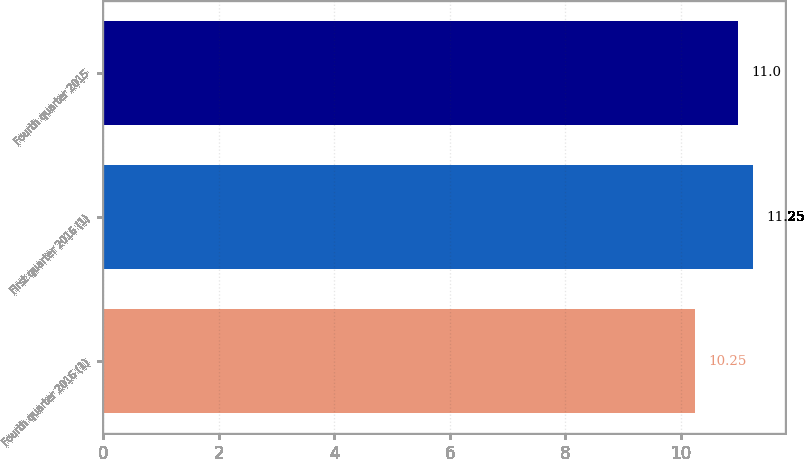<chart> <loc_0><loc_0><loc_500><loc_500><bar_chart><fcel>Fourth quarter 2016 (1)<fcel>First quarter 2016 (1)<fcel>Fourth quarter 2015<nl><fcel>10.25<fcel>11.25<fcel>11<nl></chart> 